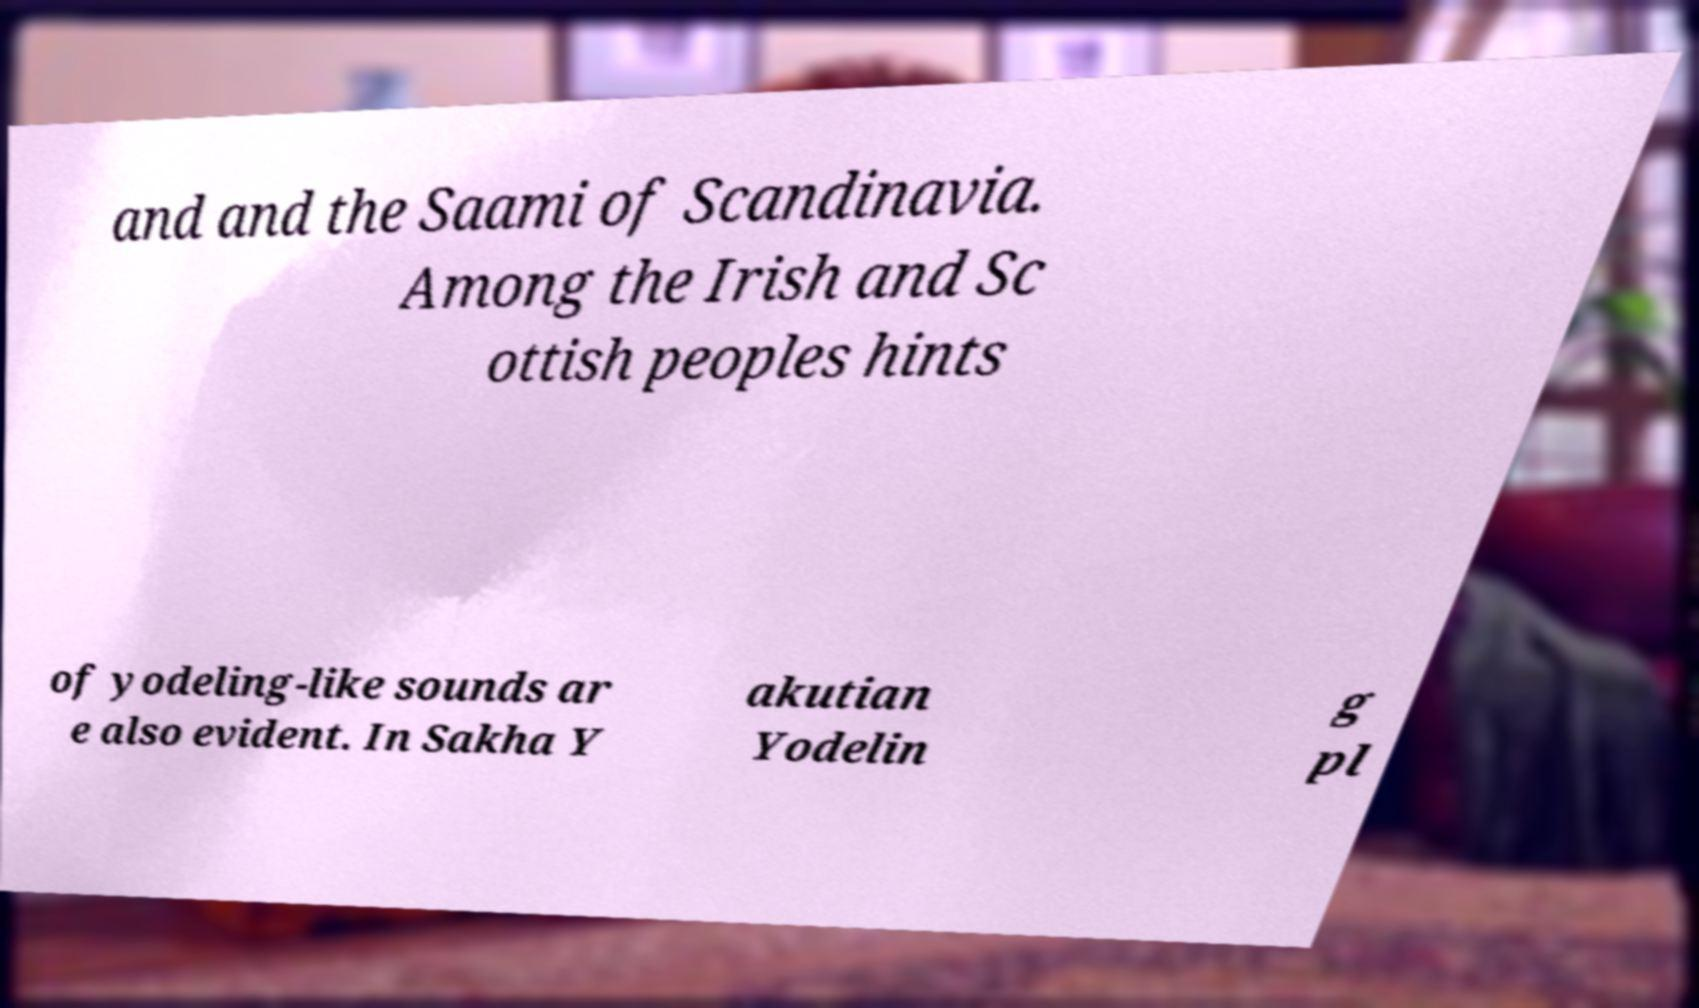Could you assist in decoding the text presented in this image and type it out clearly? and and the Saami of Scandinavia. Among the Irish and Sc ottish peoples hints of yodeling-like sounds ar e also evident. In Sakha Y akutian Yodelin g pl 